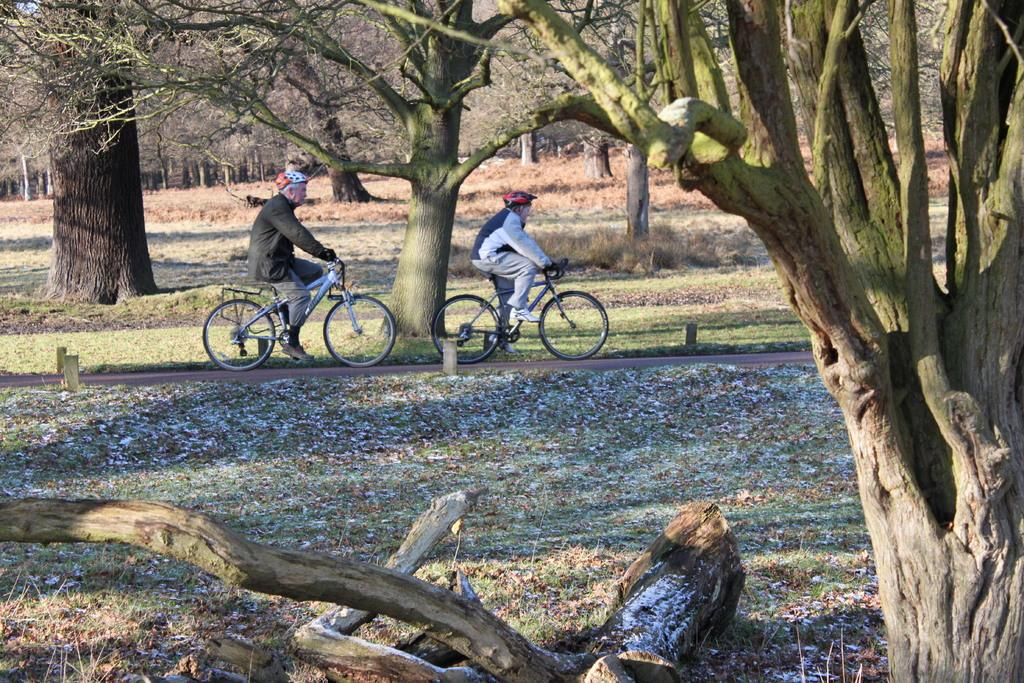Who or what is present in the image? There are people in the image. What are the people doing in the image? The people are sitting on bicycles. Where are the people located in the image? The people are standing on the road. What can be seen in the background of the image? There are trees visible in the background of the image. Where is the faucet located in the image? There is no faucet present in the image. What type of ant can be seen crawling on the road in the image? There are no ants present in the image; it features people sitting on bicycles on the road. 